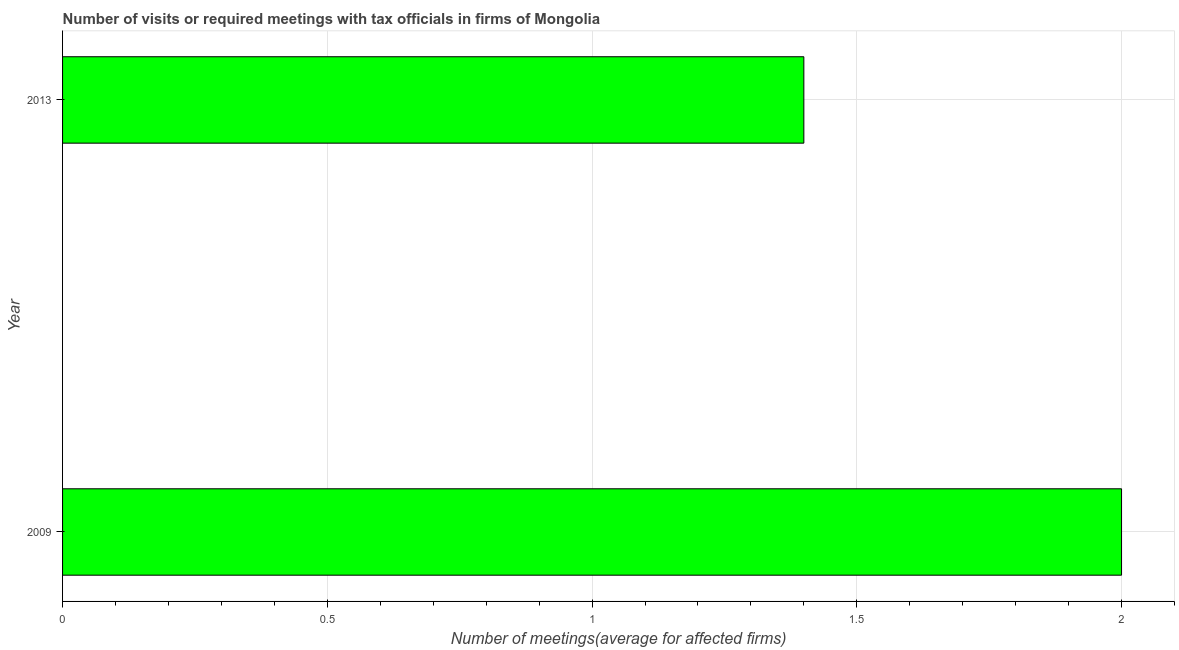Does the graph contain any zero values?
Your answer should be compact. No. What is the title of the graph?
Keep it short and to the point. Number of visits or required meetings with tax officials in firms of Mongolia. What is the label or title of the X-axis?
Your response must be concise. Number of meetings(average for affected firms). What is the number of required meetings with tax officials in 2009?
Your answer should be very brief. 2. Across all years, what is the minimum number of required meetings with tax officials?
Offer a terse response. 1.4. In which year was the number of required meetings with tax officials minimum?
Give a very brief answer. 2013. What is the sum of the number of required meetings with tax officials?
Ensure brevity in your answer.  3.4. What is the average number of required meetings with tax officials per year?
Offer a very short reply. 1.7. In how many years, is the number of required meetings with tax officials greater than 0.6 ?
Give a very brief answer. 2. What is the ratio of the number of required meetings with tax officials in 2009 to that in 2013?
Make the answer very short. 1.43. What is the ratio of the Number of meetings(average for affected firms) in 2009 to that in 2013?
Make the answer very short. 1.43. 